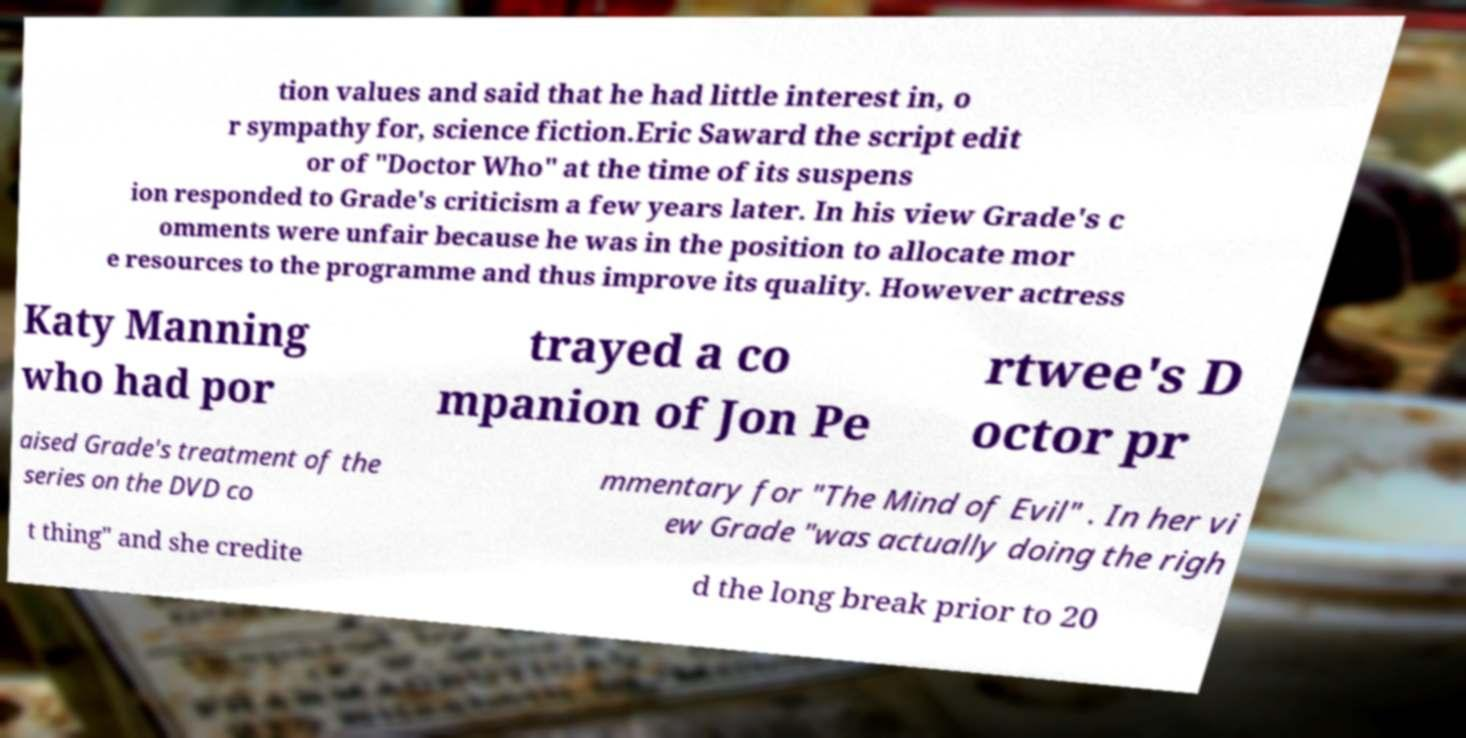Could you extract and type out the text from this image? tion values and said that he had little interest in, o r sympathy for, science fiction.Eric Saward the script edit or of "Doctor Who" at the time of its suspens ion responded to Grade's criticism a few years later. In his view Grade's c omments were unfair because he was in the position to allocate mor e resources to the programme and thus improve its quality. However actress Katy Manning who had por trayed a co mpanion of Jon Pe rtwee's D octor pr aised Grade's treatment of the series on the DVD co mmentary for "The Mind of Evil" . In her vi ew Grade "was actually doing the righ t thing" and she credite d the long break prior to 20 